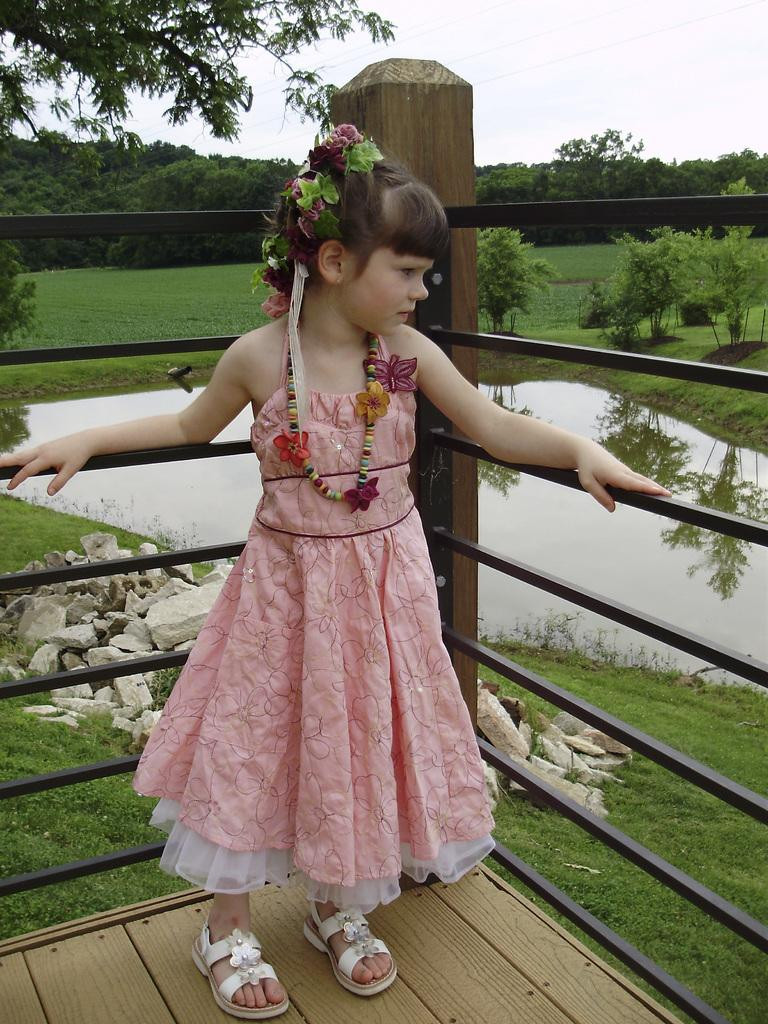What is the main subject of the image? There is a girl standing in the image. Where is the girl standing? The girl is standing on the floor. What can be seen in the background of the image? The sky is visible in the background of the image. What type of vegetation is present in the image? Plants, trees, and grass are present in the image. What else can be seen in the image besides the girl? There is a fence, stones, and water visible in the image. What type of instrument is the girl playing in the image? There is no instrument present in the image, and the girl is not playing any instrument. Can you tell me how many hydrants are visible in the image? There are no hydrants present in the image. 